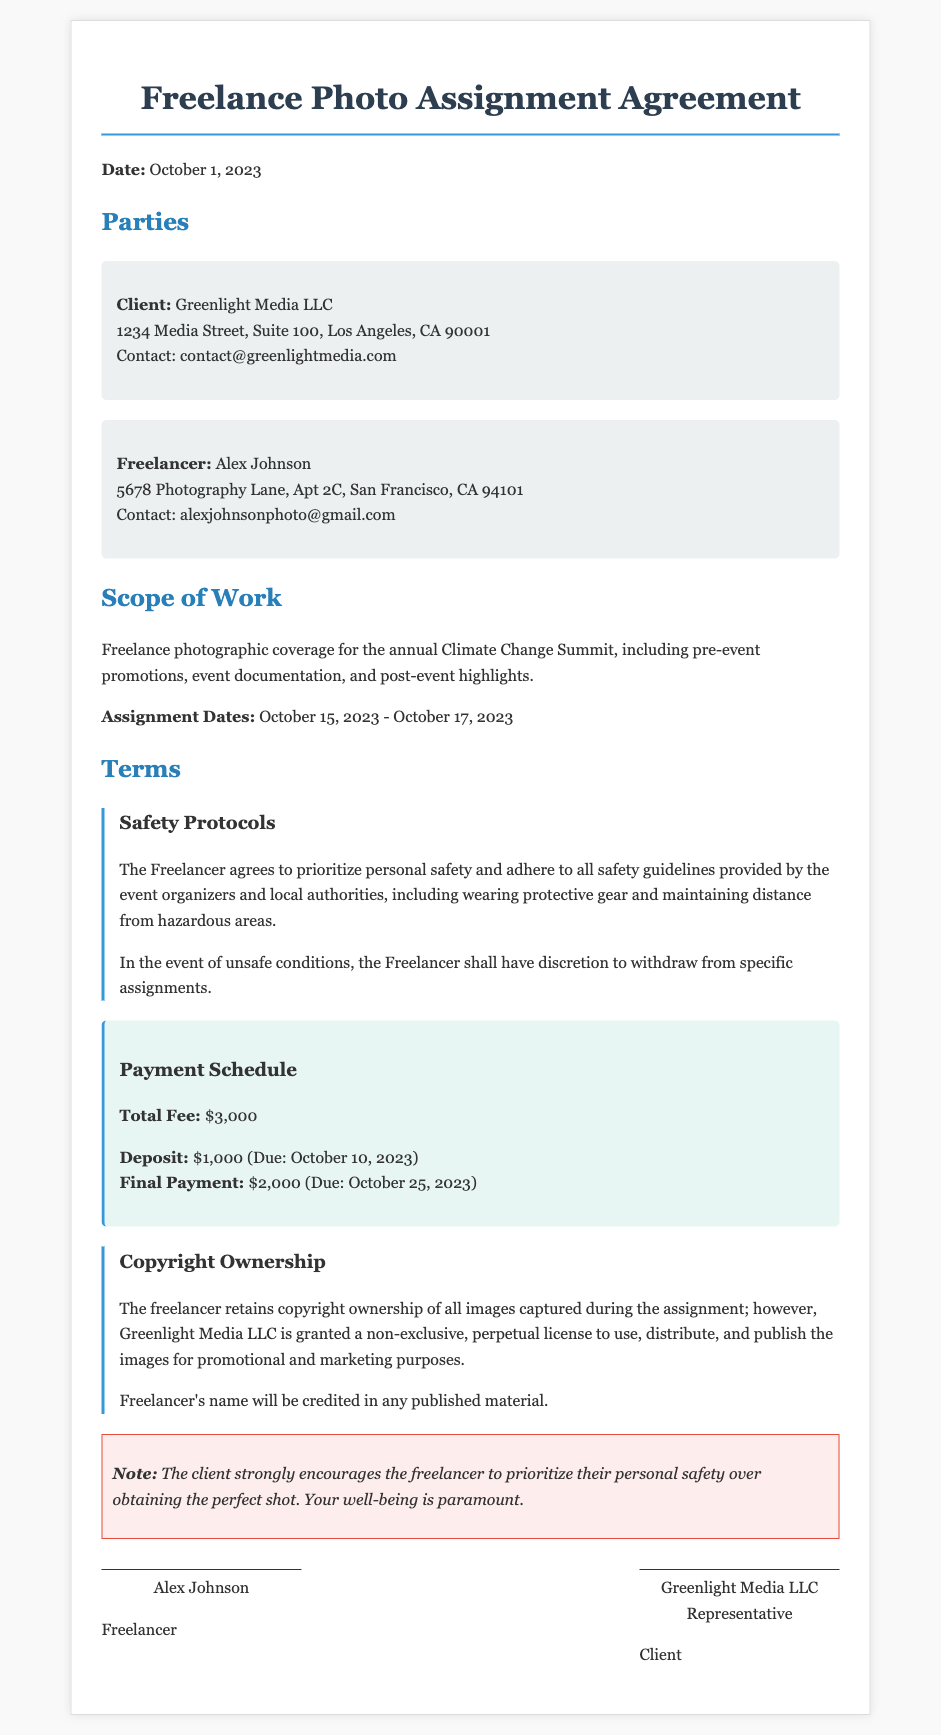What is the client's name? The client's name is specified in the document under the "Parties" section.
Answer: Greenlight Media LLC What is the total fee for the project? The total fee is referenced in the "Payment Schedule" section of the document.
Answer: $3,000 What are the assignment dates? The assignment dates are provided in the "Scope of Work" section of the contract.
Answer: October 15, 2023 - October 17, 2023 What is the deposit amount due? The deposit amount is listed under the "Payment Schedule" section of the agreement.
Answer: $1,000 What safety protocols must the freelancer adhere to? The document outlines safety protocols under the "Safety Protocols" subsection.
Answer: Prioritize personal safety and adhere to all safety guidelines provided What happens if conditions are unsafe? The terms regarding unsafe conditions are found in the "Safety Protocols" section.
Answer: The Freelancer shall have discretion to withdraw from specific assignments What type of license does the client receive for the images? The type of license is specified in the "Copyright Ownership" section.
Answer: Non-exclusive, perpetual license Who will be credited in published material? The crediting is mentioned in the "Copyright Ownership" section of the document.
Answer: Freelancer's name What is the final payment due date? The due date for the final payment is detailed in the "Payment Schedule" section.
Answer: October 25, 2023 